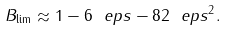Convert formula to latex. <formula><loc_0><loc_0><loc_500><loc_500>\ B _ { \lim } \approx 1 - 6 \ e p s - 8 2 \ e p s ^ { 2 } .</formula> 